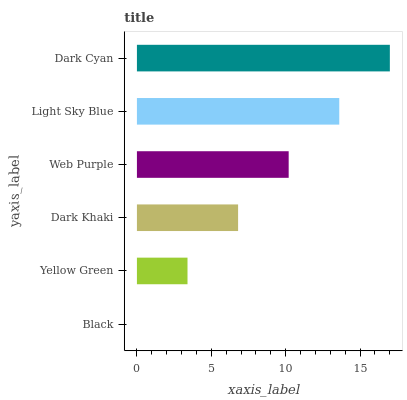Is Black the minimum?
Answer yes or no. Yes. Is Dark Cyan the maximum?
Answer yes or no. Yes. Is Yellow Green the minimum?
Answer yes or no. No. Is Yellow Green the maximum?
Answer yes or no. No. Is Yellow Green greater than Black?
Answer yes or no. Yes. Is Black less than Yellow Green?
Answer yes or no. Yes. Is Black greater than Yellow Green?
Answer yes or no. No. Is Yellow Green less than Black?
Answer yes or no. No. Is Web Purple the high median?
Answer yes or no. Yes. Is Dark Khaki the low median?
Answer yes or no. Yes. Is Dark Cyan the high median?
Answer yes or no. No. Is Web Purple the low median?
Answer yes or no. No. 